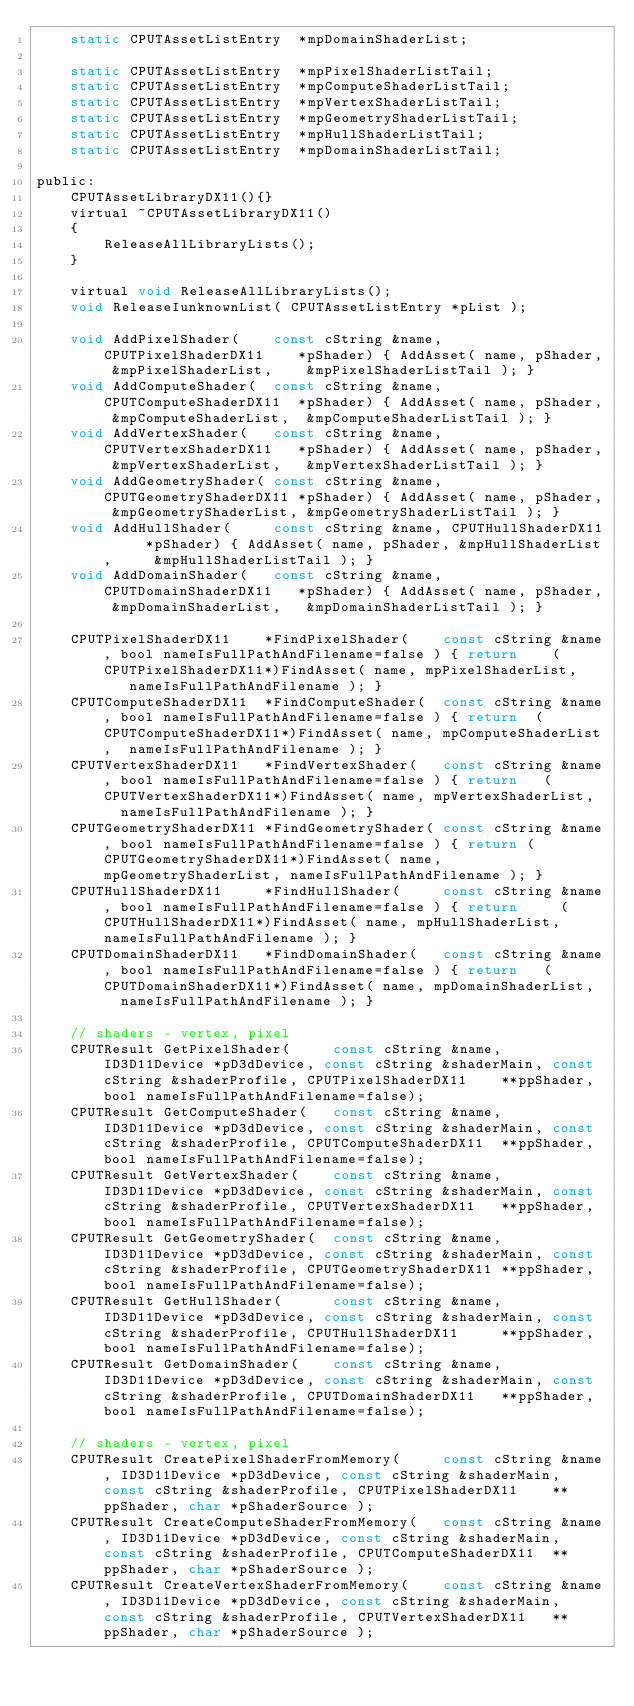<code> <loc_0><loc_0><loc_500><loc_500><_C_>    static CPUTAssetListEntry  *mpDomainShaderList;

    static CPUTAssetListEntry  *mpPixelShaderListTail;
    static CPUTAssetListEntry  *mpComputeShaderListTail;
    static CPUTAssetListEntry  *mpVertexShaderListTail;
    static CPUTAssetListEntry  *mpGeometryShaderListTail;
    static CPUTAssetListEntry  *mpHullShaderListTail;
    static CPUTAssetListEntry  *mpDomainShaderListTail;

public:
    CPUTAssetLibraryDX11(){}
    virtual ~CPUTAssetLibraryDX11()
    {
        ReleaseAllLibraryLists();
    }

    virtual void ReleaseAllLibraryLists();
    void ReleaseIunknownList( CPUTAssetListEntry *pList );

    void AddPixelShader(    const cString &name, CPUTPixelShaderDX11    *pShader) { AddAsset( name, pShader, &mpPixelShaderList,    &mpPixelShaderListTail ); }
    void AddComputeShader(  const cString &name, CPUTComputeShaderDX11  *pShader) { AddAsset( name, pShader, &mpComputeShaderList,  &mpComputeShaderListTail ); }
    void AddVertexShader(   const cString &name, CPUTVertexShaderDX11   *pShader) { AddAsset( name, pShader, &mpVertexShaderList,   &mpVertexShaderListTail ); }
    void AddGeometryShader( const cString &name, CPUTGeometryShaderDX11 *pShader) { AddAsset( name, pShader, &mpGeometryShaderList, &mpGeometryShaderListTail ); }
    void AddHullShader(     const cString &name, CPUTHullShaderDX11     *pShader) { AddAsset( name, pShader, &mpHullShaderList,     &mpHullShaderListTail ); }
    void AddDomainShader(   const cString &name, CPUTDomainShaderDX11   *pShader) { AddAsset( name, pShader, &mpDomainShaderList,   &mpDomainShaderListTail ); }
    
    CPUTPixelShaderDX11    *FindPixelShader(    const cString &name, bool nameIsFullPathAndFilename=false ) { return    (CPUTPixelShaderDX11*)FindAsset( name, mpPixelShaderList,    nameIsFullPathAndFilename ); }
    CPUTComputeShaderDX11  *FindComputeShader(  const cString &name, bool nameIsFullPathAndFilename=false ) { return  (CPUTComputeShaderDX11*)FindAsset( name, mpComputeShaderList,  nameIsFullPathAndFilename ); }
    CPUTVertexShaderDX11   *FindVertexShader(   const cString &name, bool nameIsFullPathAndFilename=false ) { return   (CPUTVertexShaderDX11*)FindAsset( name, mpVertexShaderList,   nameIsFullPathAndFilename ); }
    CPUTGeometryShaderDX11 *FindGeometryShader( const cString &name, bool nameIsFullPathAndFilename=false ) { return (CPUTGeometryShaderDX11*)FindAsset( name, mpGeometryShaderList, nameIsFullPathAndFilename ); }
    CPUTHullShaderDX11     *FindHullShader(     const cString &name, bool nameIsFullPathAndFilename=false ) { return     (CPUTHullShaderDX11*)FindAsset( name, mpHullShaderList,     nameIsFullPathAndFilename ); }
    CPUTDomainShaderDX11   *FindDomainShader(   const cString &name, bool nameIsFullPathAndFilename=false ) { return   (CPUTDomainShaderDX11*)FindAsset( name, mpDomainShaderList,   nameIsFullPathAndFilename ); }

    // shaders - vertex, pixel
    CPUTResult GetPixelShader(     const cString &name, ID3D11Device *pD3dDevice, const cString &shaderMain, const cString &shaderProfile, CPUTPixelShaderDX11    **ppShader, bool nameIsFullPathAndFilename=false);
    CPUTResult GetComputeShader(   const cString &name, ID3D11Device *pD3dDevice, const cString &shaderMain, const cString &shaderProfile, CPUTComputeShaderDX11  **ppShader, bool nameIsFullPathAndFilename=false);
    CPUTResult GetVertexShader(    const cString &name, ID3D11Device *pD3dDevice, const cString &shaderMain, const cString &shaderProfile, CPUTVertexShaderDX11   **ppShader, bool nameIsFullPathAndFilename=false);
    CPUTResult GetGeometryShader(  const cString &name, ID3D11Device *pD3dDevice, const cString &shaderMain, const cString &shaderProfile, CPUTGeometryShaderDX11 **ppShader, bool nameIsFullPathAndFilename=false);
    CPUTResult GetHullShader(      const cString &name, ID3D11Device *pD3dDevice, const cString &shaderMain, const cString &shaderProfile, CPUTHullShaderDX11     **ppShader, bool nameIsFullPathAndFilename=false);
    CPUTResult GetDomainShader(    const cString &name, ID3D11Device *pD3dDevice, const cString &shaderMain, const cString &shaderProfile, CPUTDomainShaderDX11   **ppShader, bool nameIsFullPathAndFilename=false);
 
    // shaders - vertex, pixel
    CPUTResult CreatePixelShaderFromMemory(     const cString &name, ID3D11Device *pD3dDevice, const cString &shaderMain, const cString &shaderProfile, CPUTPixelShaderDX11    **ppShader, char *pShaderSource );
    CPUTResult CreateComputeShaderFromMemory(   const cString &name, ID3D11Device *pD3dDevice, const cString &shaderMain, const cString &shaderProfile, CPUTComputeShaderDX11  **ppShader, char *pShaderSource );
    CPUTResult CreateVertexShaderFromMemory(    const cString &name, ID3D11Device *pD3dDevice, const cString &shaderMain, const cString &shaderProfile, CPUTVertexShaderDX11   **ppShader, char *pShaderSource );</code> 